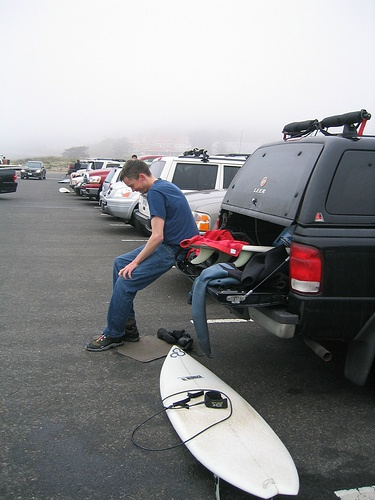Describe the objects in this image and their specific colors. I can see truck in white, black, gray, darkgray, and darkblue tones, car in white, black, gray, darkgray, and darkblue tones, surfboard in white, lightgray, black, darkgray, and gray tones, people in white, darkblue, navy, black, and gray tones, and car in white, lightgray, gray, darkgray, and black tones in this image. 